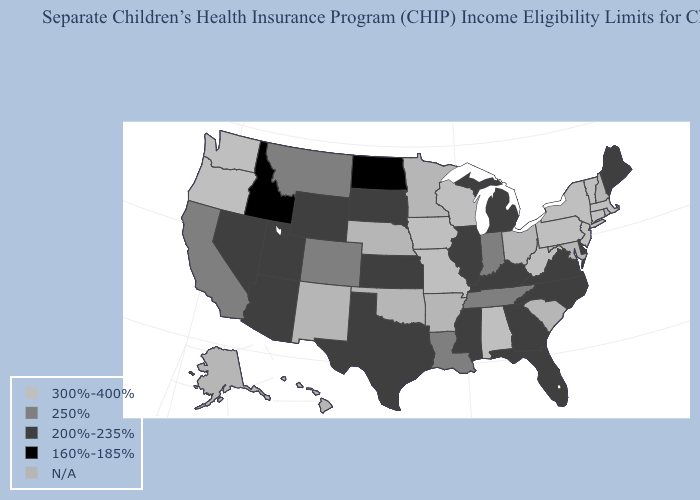What is the value of New York?
Give a very brief answer. 300%-400%. What is the value of Utah?
Keep it brief. 200%-235%. Which states have the lowest value in the USA?
Short answer required. Idaho, North Dakota. Name the states that have a value in the range 300%-400%?
Give a very brief answer. Alabama, Connecticut, Iowa, Massachusetts, Missouri, New Jersey, New York, Oregon, Pennsylvania, Vermont, Washington, West Virginia, Wisconsin. Which states hav the highest value in the West?
Quick response, please. Oregon, Washington. Does Idaho have the lowest value in the West?
Short answer required. Yes. What is the value of Washington?
Be succinct. 300%-400%. What is the value of North Carolina?
Quick response, please. 200%-235%. Among the states that border Pennsylvania , which have the lowest value?
Write a very short answer. Delaware. Does the map have missing data?
Quick response, please. Yes. What is the lowest value in states that border Iowa?
Quick response, please. 200%-235%. Which states have the highest value in the USA?
Short answer required. Alabama, Connecticut, Iowa, Massachusetts, Missouri, New Jersey, New York, Oregon, Pennsylvania, Vermont, Washington, West Virginia, Wisconsin. 